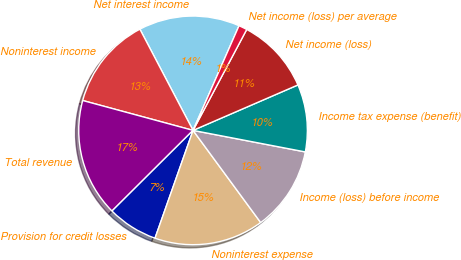Convert chart to OTSL. <chart><loc_0><loc_0><loc_500><loc_500><pie_chart><fcel>Net interest income<fcel>Noninterest income<fcel>Total revenue<fcel>Provision for credit losses<fcel>Noninterest expense<fcel>Income (loss) before income<fcel>Income tax expense (benefit)<fcel>Net income (loss)<fcel>Net income (loss) per average<nl><fcel>14.28%<fcel>13.09%<fcel>16.66%<fcel>7.14%<fcel>15.47%<fcel>11.9%<fcel>9.52%<fcel>10.71%<fcel>1.19%<nl></chart> 